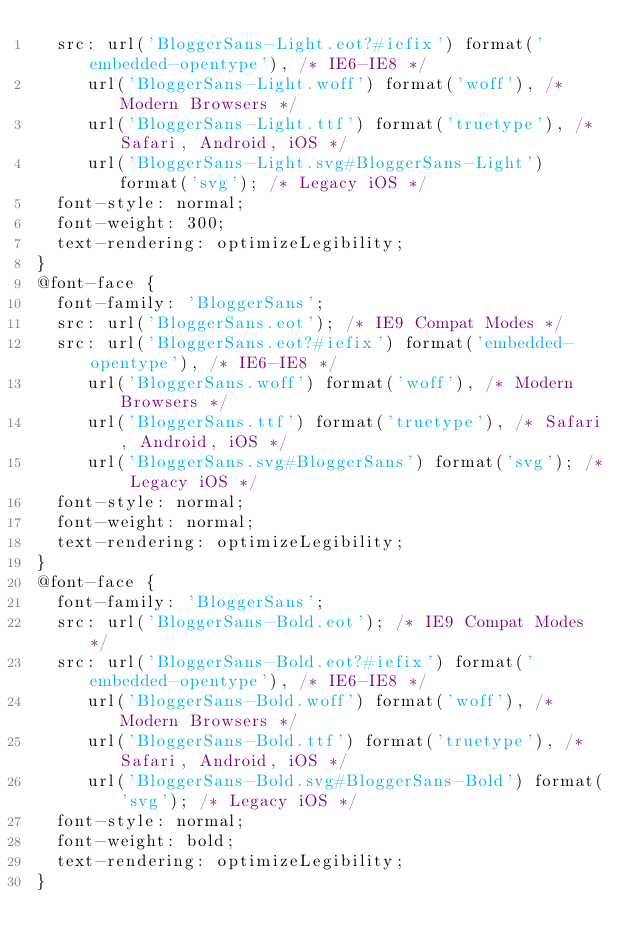<code> <loc_0><loc_0><loc_500><loc_500><_CSS_>	src: url('BloggerSans-Light.eot?#iefix') format('embedded-opentype'), /* IE6-IE8 */
		 url('BloggerSans-Light.woff') format('woff'), /* Modern Browsers */
		 url('BloggerSans-Light.ttf') format('truetype'), /* Safari, Android, iOS */
		 url('BloggerSans-Light.svg#BloggerSans-Light') format('svg'); /* Legacy iOS */
	font-style: normal;
	font-weight: 300;
	text-rendering: optimizeLegibility;
}
@font-face {
	font-family: 'BloggerSans';
	src: url('BloggerSans.eot'); /* IE9 Compat Modes */
	src: url('BloggerSans.eot?#iefix') format('embedded-opentype'), /* IE6-IE8 */
		 url('BloggerSans.woff') format('woff'), /* Modern Browsers */
		 url('BloggerSans.ttf') format('truetype'), /* Safari, Android, iOS */
		 url('BloggerSans.svg#BloggerSans') format('svg'); /* Legacy iOS */
	font-style: normal;
	font-weight: normal;
	text-rendering: optimizeLegibility;
}
@font-face {
	font-family: 'BloggerSans';
	src: url('BloggerSans-Bold.eot'); /* IE9 Compat Modes */
	src: url('BloggerSans-Bold.eot?#iefix') format('embedded-opentype'), /* IE6-IE8 */
		 url('BloggerSans-Bold.woff') format('woff'), /* Modern Browsers */
		 url('BloggerSans-Bold.ttf') format('truetype'), /* Safari, Android, iOS */
		 url('BloggerSans-Bold.svg#BloggerSans-Bold') format('svg'); /* Legacy iOS */
	font-style: normal;
	font-weight: bold;
	text-rendering: optimizeLegibility;
}</code> 